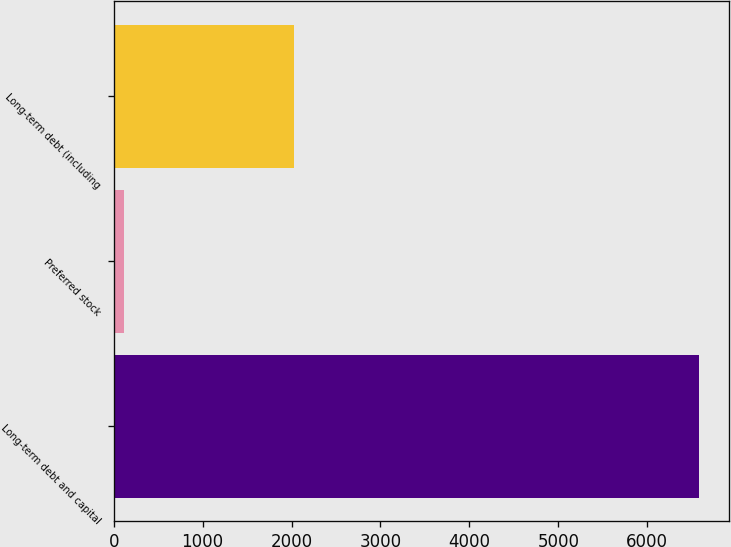Convert chart. <chart><loc_0><loc_0><loc_500><loc_500><bar_chart><fcel>Long-term debt and capital<fcel>Preferred stock<fcel>Long-term debt (including<nl><fcel>6584<fcel>118<fcel>2028<nl></chart> 